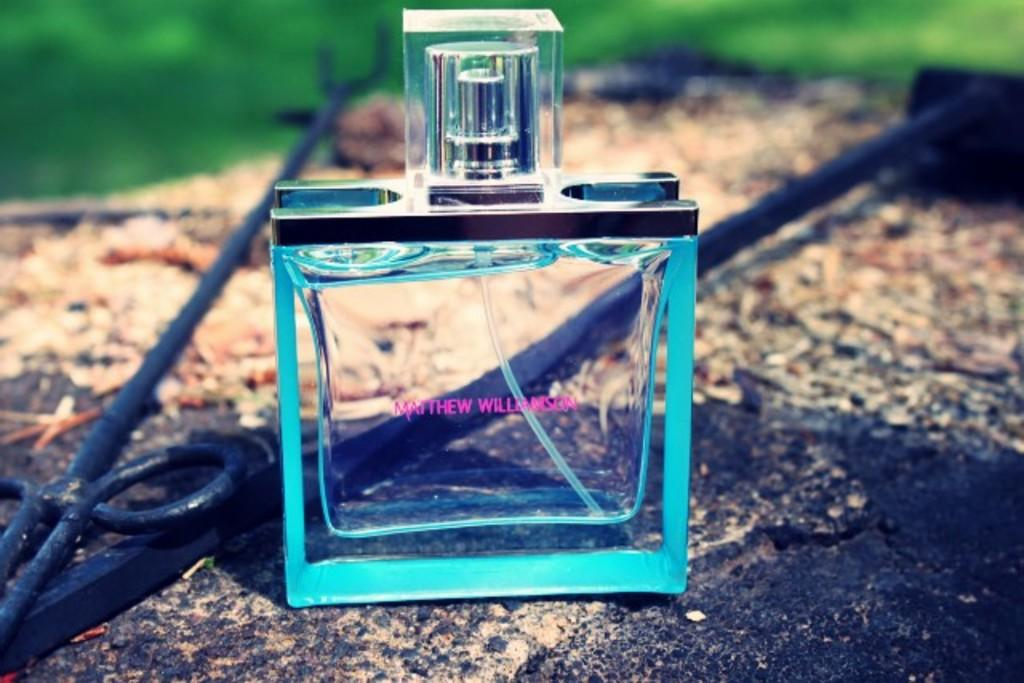<image>
Render a clear and concise summary of the photo. A bottle of Matthew Williamson that is on the ground. 